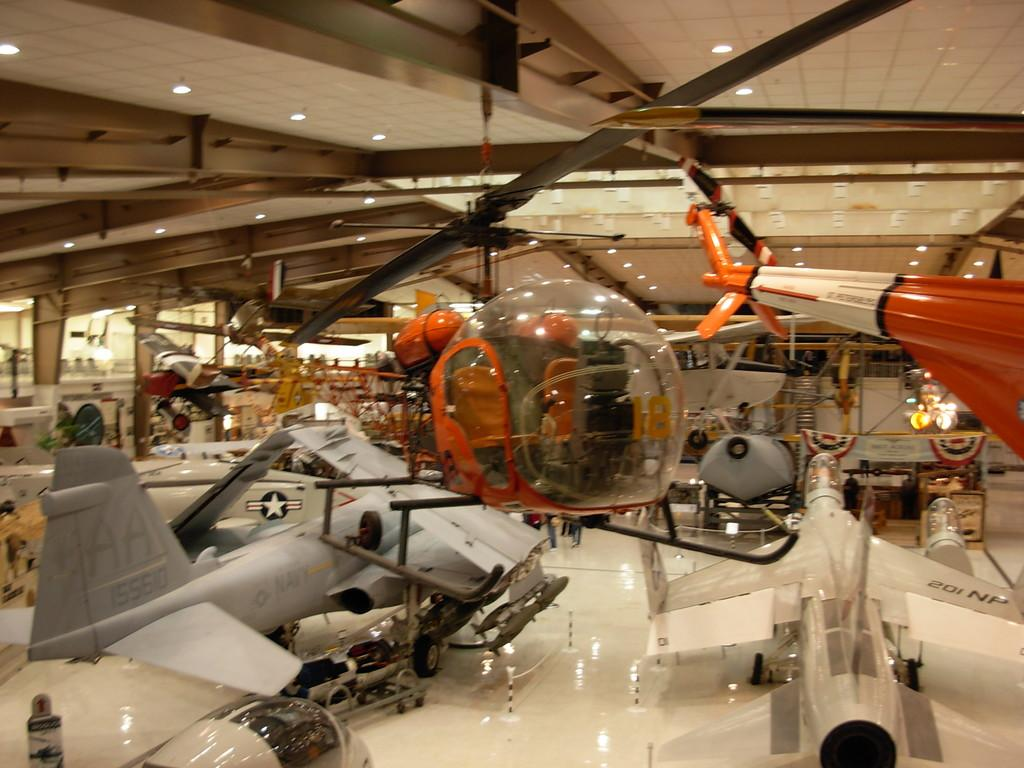What is the main subject of the image? The main subject of the image is many aircrafts. Can you describe any additional features in the image? Yes, there are lights attached to a roof in the image. What type of coal is being used to fuel the aircrafts in the image? There is no coal present in the image, and the aircrafts are not shown being fueled. 